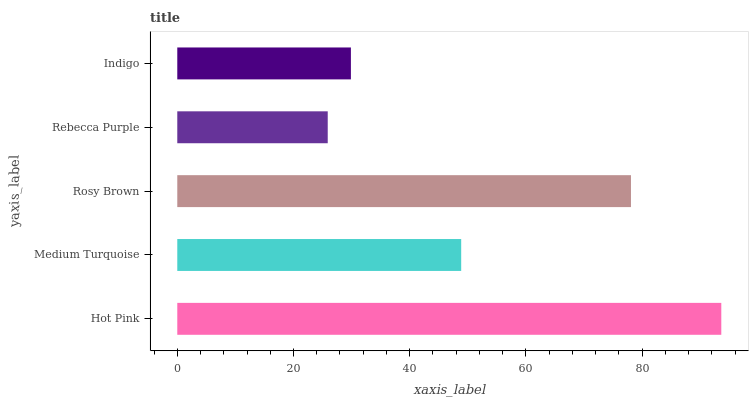Is Rebecca Purple the minimum?
Answer yes or no. Yes. Is Hot Pink the maximum?
Answer yes or no. Yes. Is Medium Turquoise the minimum?
Answer yes or no. No. Is Medium Turquoise the maximum?
Answer yes or no. No. Is Hot Pink greater than Medium Turquoise?
Answer yes or no. Yes. Is Medium Turquoise less than Hot Pink?
Answer yes or no. Yes. Is Medium Turquoise greater than Hot Pink?
Answer yes or no. No. Is Hot Pink less than Medium Turquoise?
Answer yes or no. No. Is Medium Turquoise the high median?
Answer yes or no. Yes. Is Medium Turquoise the low median?
Answer yes or no. Yes. Is Rosy Brown the high median?
Answer yes or no. No. Is Rebecca Purple the low median?
Answer yes or no. No. 